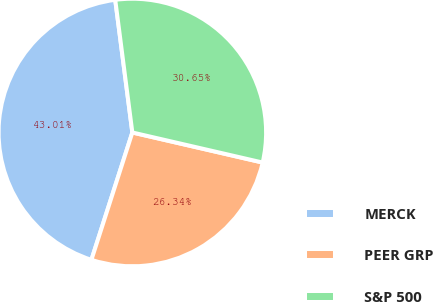Convert chart to OTSL. <chart><loc_0><loc_0><loc_500><loc_500><pie_chart><fcel>MERCK<fcel>PEER GRP<fcel>S&P 500<nl><fcel>43.01%<fcel>26.34%<fcel>30.65%<nl></chart> 